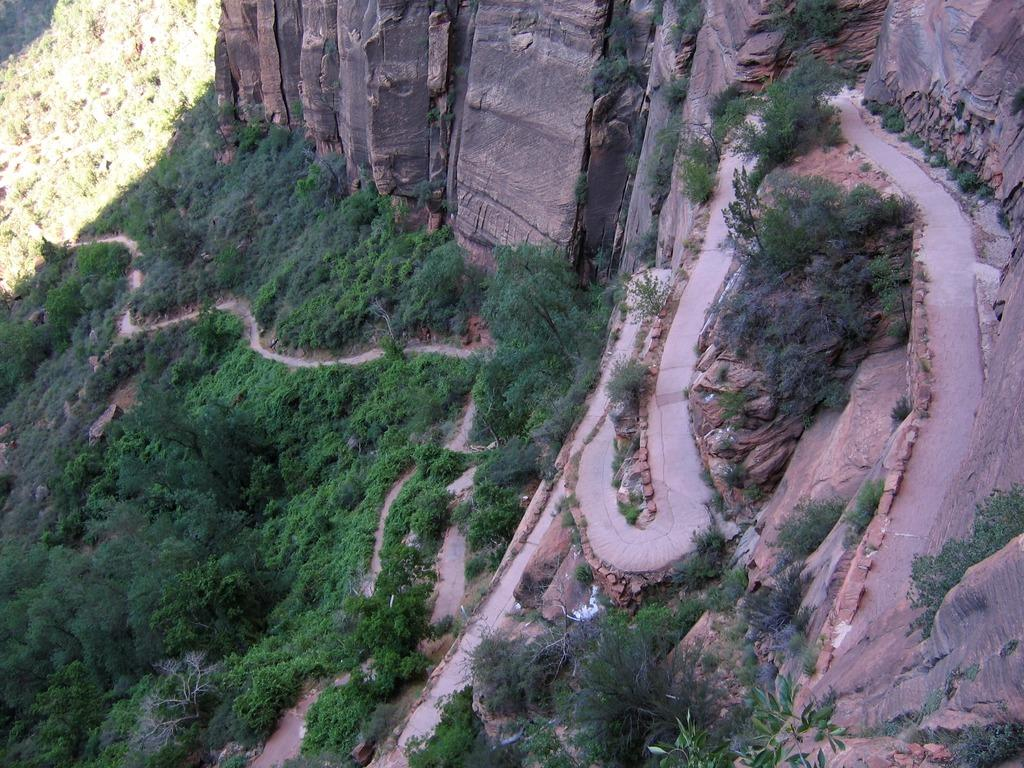What is the main feature of the landscape in the image? There is a path in the image. What type of vegetation is present in the image? There are trees in the image. What other natural elements can be seen in the image? There are rocks in the image. Where are the rocks located in relation to the landscape? The rocks are on hills in the image. What type of pancake is being served on the stem of the tree in the image? There is no pancake or tree with a stem present in the image. 